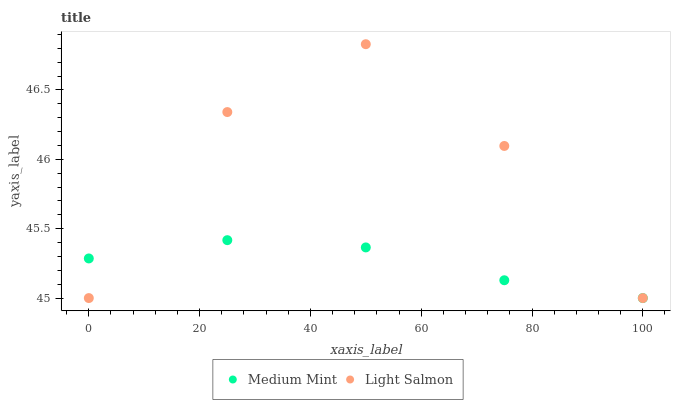Does Medium Mint have the minimum area under the curve?
Answer yes or no. Yes. Does Light Salmon have the maximum area under the curve?
Answer yes or no. Yes. Does Light Salmon have the minimum area under the curve?
Answer yes or no. No. Is Medium Mint the smoothest?
Answer yes or no. Yes. Is Light Salmon the roughest?
Answer yes or no. Yes. Is Light Salmon the smoothest?
Answer yes or no. No. Does Medium Mint have the lowest value?
Answer yes or no. Yes. Does Light Salmon have the highest value?
Answer yes or no. Yes. Does Light Salmon intersect Medium Mint?
Answer yes or no. Yes. Is Light Salmon less than Medium Mint?
Answer yes or no. No. Is Light Salmon greater than Medium Mint?
Answer yes or no. No. 